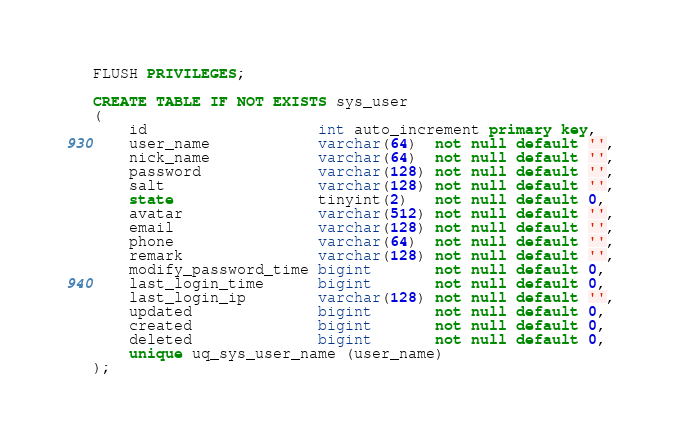<code> <loc_0><loc_0><loc_500><loc_500><_SQL_>
FLUSH PRIVILEGES;

CREATE TABLE IF NOT EXISTS sys_user
(
    id                   int auto_increment primary key,
    user_name            varchar(64)  not null default '',
    nick_name            varchar(64)  not null default '',
    password             varchar(128) not null default '',
    salt                 varchar(128) not null default '',
    state                tinyint(2)   not null default 0,
    avatar               varchar(512) not null default '',
    email                varchar(128) not null default '',
    phone                varchar(64)  not null default '',
    remark               varchar(128) not null default '',
    modify_password_time bigint       not null default 0,
    last_login_time      bigint       not null default 0,
    last_login_ip        varchar(128) not null default '',
    updated              bigint       not null default 0,
    created              bigint       not null default 0,
    deleted              bigint       not null default 0,
    unique uq_sys_user_name (user_name)
);
</code> 